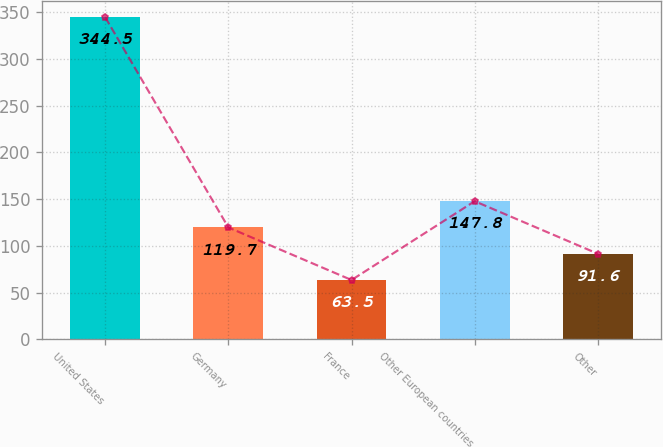Convert chart to OTSL. <chart><loc_0><loc_0><loc_500><loc_500><bar_chart><fcel>United States<fcel>Germany<fcel>France<fcel>Other European countries<fcel>Other<nl><fcel>344.5<fcel>119.7<fcel>63.5<fcel>147.8<fcel>91.6<nl></chart> 